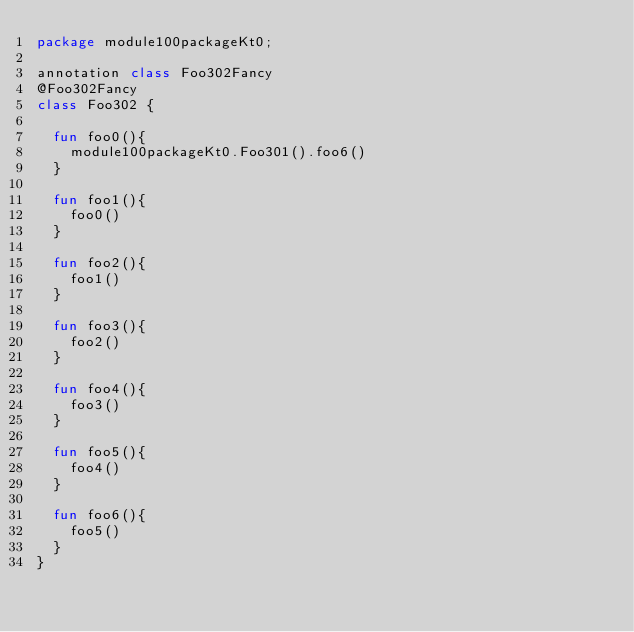Convert code to text. <code><loc_0><loc_0><loc_500><loc_500><_Kotlin_>package module100packageKt0;

annotation class Foo302Fancy
@Foo302Fancy
class Foo302 {

  fun foo0(){
    module100packageKt0.Foo301().foo6()
  }

  fun foo1(){
    foo0()
  }

  fun foo2(){
    foo1()
  }

  fun foo3(){
    foo2()
  }

  fun foo4(){
    foo3()
  }

  fun foo5(){
    foo4()
  }

  fun foo6(){
    foo5()
  }
}</code> 